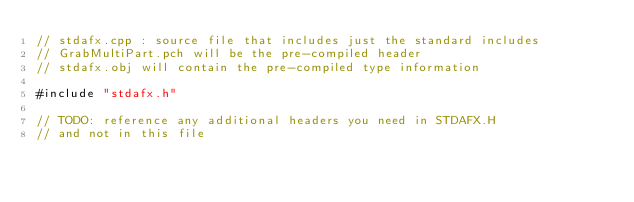<code> <loc_0><loc_0><loc_500><loc_500><_C++_>// stdafx.cpp : source file that includes just the standard includes
// GrabMultiPart.pch will be the pre-compiled header
// stdafx.obj will contain the pre-compiled type information

#include "stdafx.h"

// TODO: reference any additional headers you need in STDAFX.H
// and not in this file
</code> 